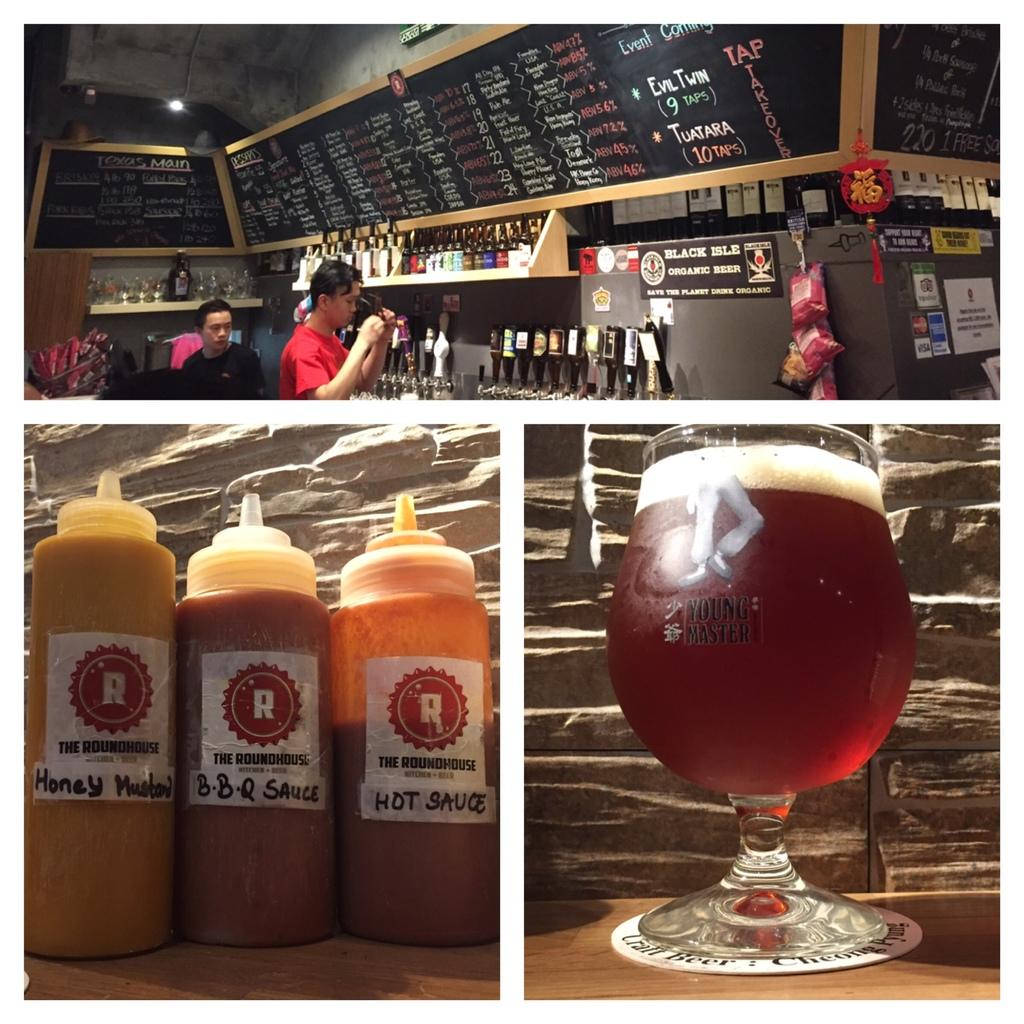<image>
Relay a brief, clear account of the picture shown. Several bottles of sauce are marked as being from "The Roundhouse." 